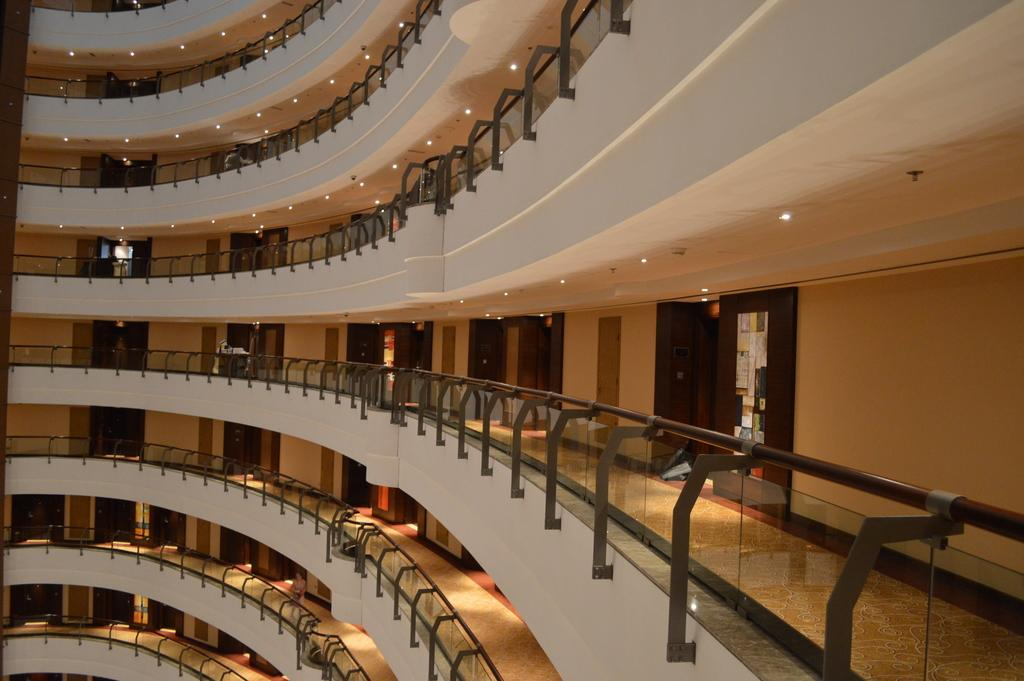What type of structure is present in the image? There is a building in the image. What features can be observed on the building? The building has doors, lights, and walls. How many cacti are growing on the walls of the building in the image? There are no cacti visible on the walls of the building in the image. 